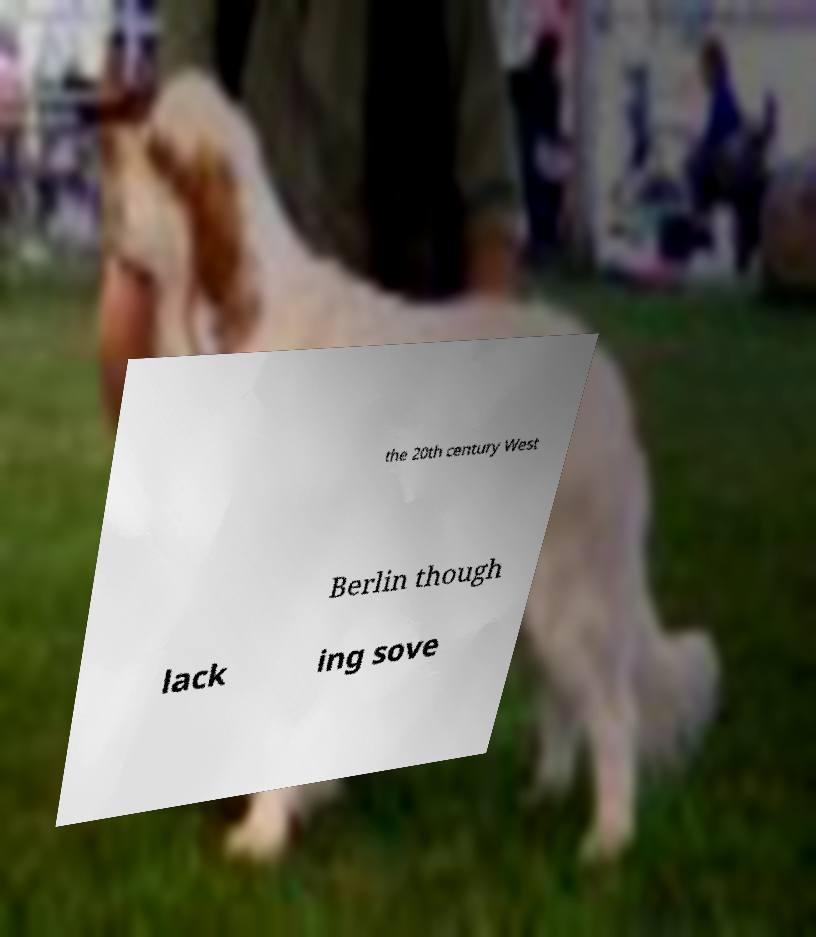There's text embedded in this image that I need extracted. Can you transcribe it verbatim? the 20th century West Berlin though lack ing sove 